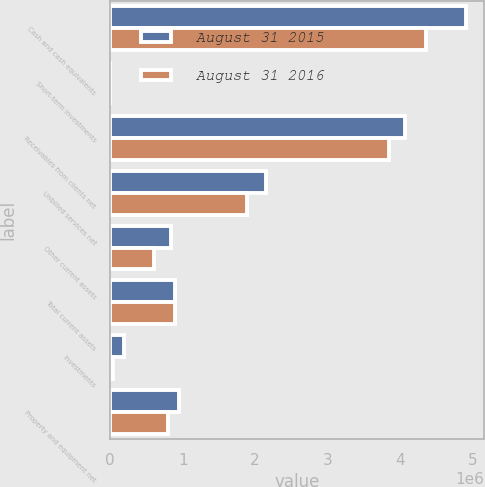Convert chart. <chart><loc_0><loc_0><loc_500><loc_500><stacked_bar_chart><ecel><fcel>Cash and cash equivalents<fcel>Short-term investments<fcel>Receivables from clients net<fcel>Unbilled services net<fcel>Other current assets<fcel>Total current assets<fcel>Investments<fcel>Property and equipment net<nl><fcel>August 31 2015<fcel>4.90561e+06<fcel>2875<fcel>4.07218e+06<fcel>2.15022e+06<fcel>845339<fcel>900940<fcel>198633<fcel>956542<nl><fcel>August 31 2016<fcel>4.36077e+06<fcel>2448<fcel>3.84092e+06<fcel>1.8845e+06<fcel>611436<fcel>900940<fcel>45027<fcel>801884<nl></chart> 